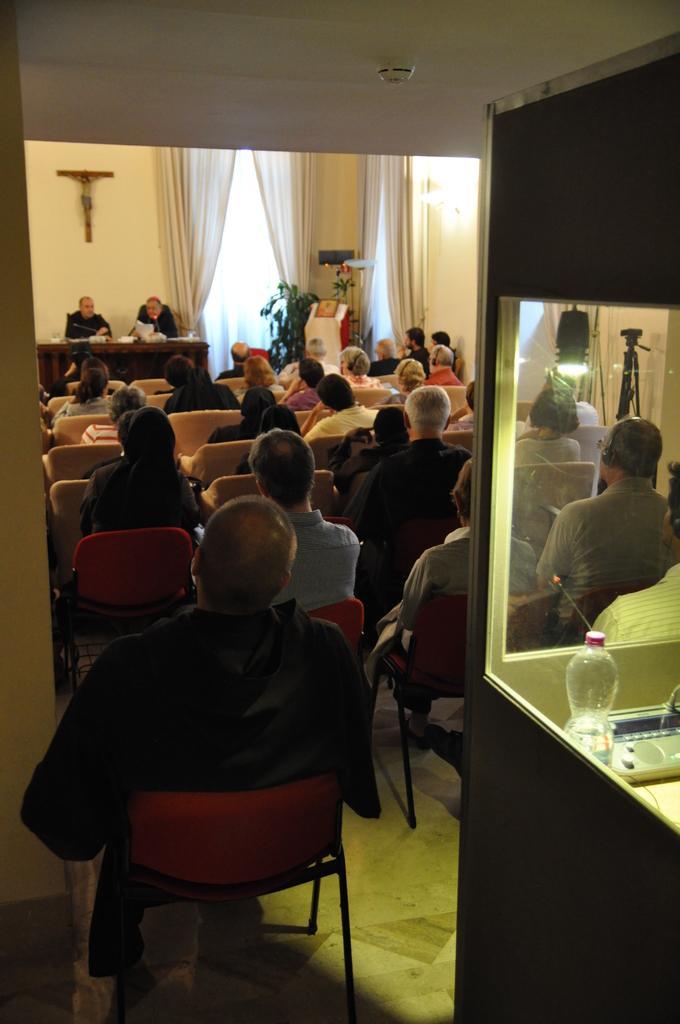How would you summarize this image in a sentence or two? In this image I can see there are group of people who are sitting on a chair. Here I can see where is the bottle and other objects on the table. 